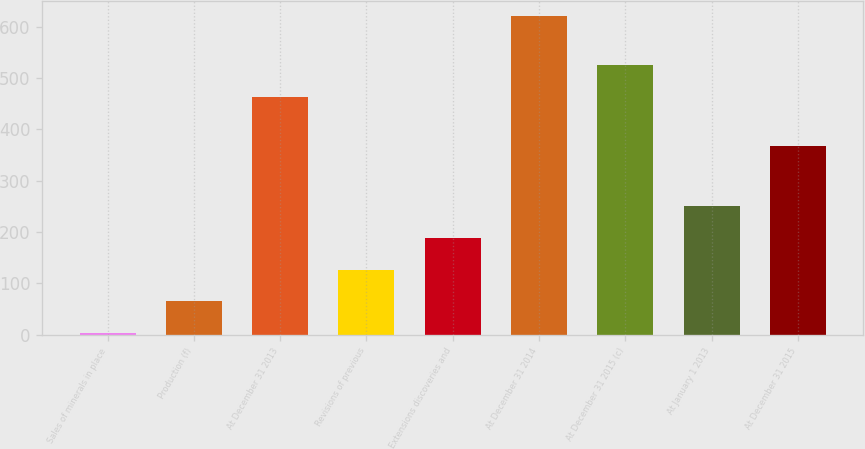<chart> <loc_0><loc_0><loc_500><loc_500><bar_chart><fcel>Sales of minerals in place<fcel>Production (f)<fcel>At December 31 2013<fcel>Revisions of previous<fcel>Extensions discoveries and<fcel>At December 31 2014<fcel>At December 31 2015 (c)<fcel>At January 1 2013<fcel>At December 31 2015<nl><fcel>4<fcel>65.6<fcel>464<fcel>127.2<fcel>188.8<fcel>620<fcel>525.6<fcel>250.4<fcel>368<nl></chart> 